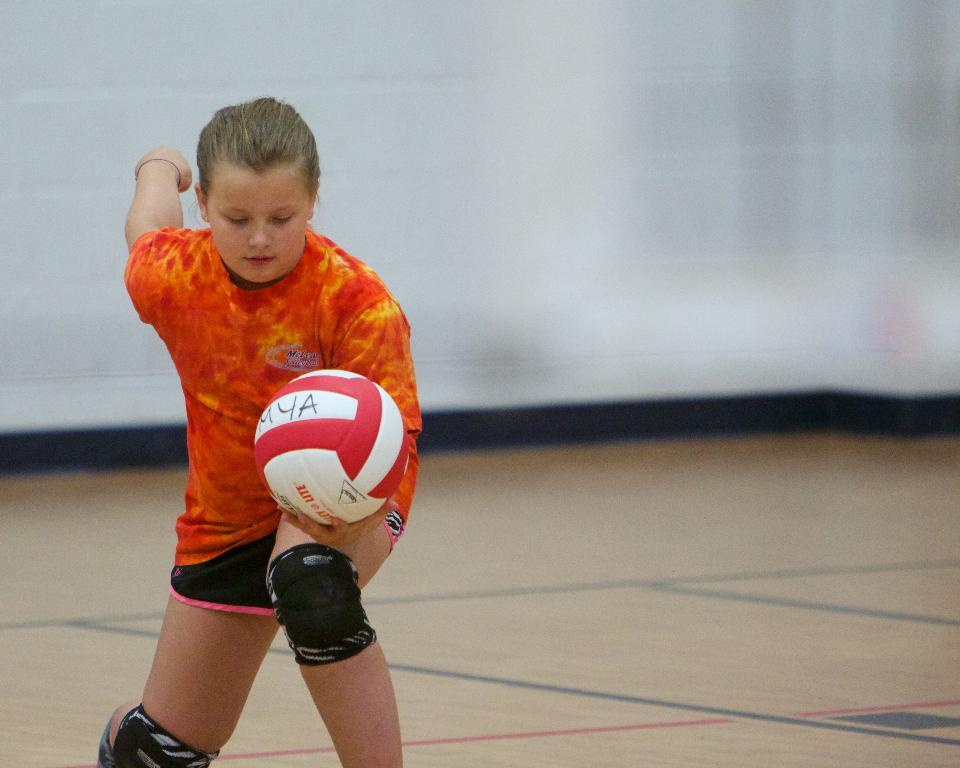What is the main subject of the image? There is a person in the image. What is the person wearing on their knees? The person is wearing knee caps. What object is the person holding? The person is holding a ball. What can be seen behind the person in the image? There is a wall in the background of the image. What is visible at the bottom of the image? There is a floor visible at the bottom of the image. How does the person use bait in the image? There is no bait present in the image, so it cannot be used by the person. 